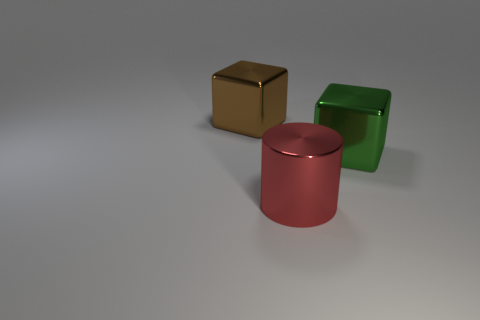Add 2 cylinders. How many objects exist? 5 Subtract all cylinders. How many objects are left? 2 Add 3 brown cubes. How many brown cubes are left? 4 Add 3 large blue metallic cubes. How many large blue metallic cubes exist? 3 Subtract 0 purple cylinders. How many objects are left? 3 Subtract all big brown cubes. Subtract all brown metal objects. How many objects are left? 1 